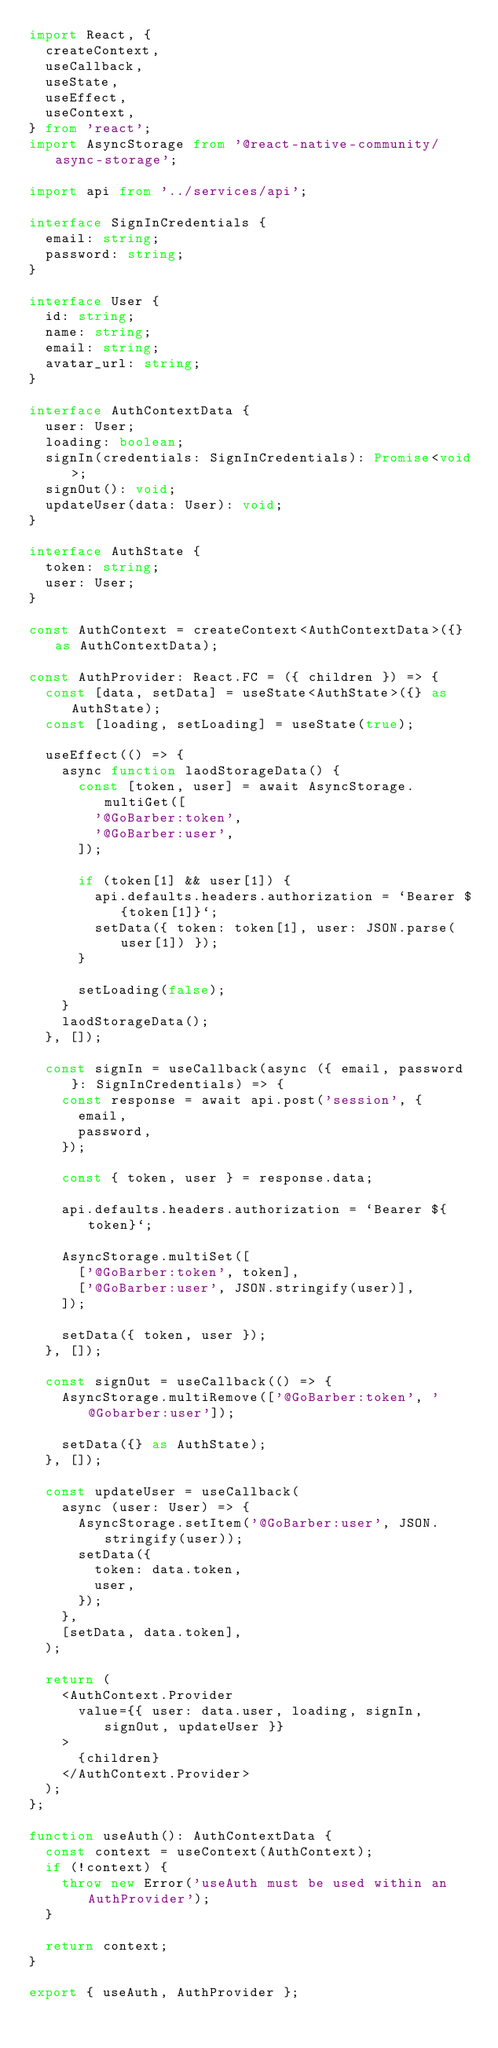<code> <loc_0><loc_0><loc_500><loc_500><_TypeScript_>import React, {
  createContext,
  useCallback,
  useState,
  useEffect,
  useContext,
} from 'react';
import AsyncStorage from '@react-native-community/async-storage';

import api from '../services/api';

interface SignInCredentials {
  email: string;
  password: string;
}

interface User {
  id: string;
  name: string;
  email: string;
  avatar_url: string;
}

interface AuthContextData {
  user: User;
  loading: boolean;
  signIn(credentials: SignInCredentials): Promise<void>;
  signOut(): void;
  updateUser(data: User): void;
}

interface AuthState {
  token: string;
  user: User;
}

const AuthContext = createContext<AuthContextData>({} as AuthContextData);

const AuthProvider: React.FC = ({ children }) => {
  const [data, setData] = useState<AuthState>({} as AuthState);
  const [loading, setLoading] = useState(true);

  useEffect(() => {
    async function laodStorageData() {
      const [token, user] = await AsyncStorage.multiGet([
        '@GoBarber:token',
        '@GoBarber:user',
      ]);

      if (token[1] && user[1]) {
        api.defaults.headers.authorization = `Bearer ${token[1]}`;
        setData({ token: token[1], user: JSON.parse(user[1]) });
      }

      setLoading(false);
    }
    laodStorageData();
  }, []);

  const signIn = useCallback(async ({ email, password }: SignInCredentials) => {
    const response = await api.post('session', {
      email,
      password,
    });

    const { token, user } = response.data;

    api.defaults.headers.authorization = `Bearer ${token}`;

    AsyncStorage.multiSet([
      ['@GoBarber:token', token],
      ['@GoBarber:user', JSON.stringify(user)],
    ]);

    setData({ token, user });
  }, []);

  const signOut = useCallback(() => {
    AsyncStorage.multiRemove(['@GoBarber:token', '@Gobarber:user']);

    setData({} as AuthState);
  }, []);

  const updateUser = useCallback(
    async (user: User) => {
      AsyncStorage.setItem('@GoBarber:user', JSON.stringify(user));
      setData({
        token: data.token,
        user,
      });
    },
    [setData, data.token],
  );

  return (
    <AuthContext.Provider
      value={{ user: data.user, loading, signIn, signOut, updateUser }}
    >
      {children}
    </AuthContext.Provider>
  );
};

function useAuth(): AuthContextData {
  const context = useContext(AuthContext);
  if (!context) {
    throw new Error('useAuth must be used within an AuthProvider');
  }

  return context;
}

export { useAuth, AuthProvider };
</code> 